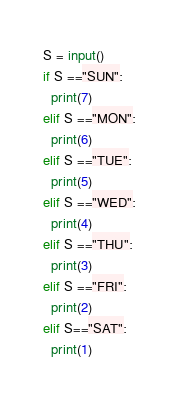Convert code to text. <code><loc_0><loc_0><loc_500><loc_500><_Python_>S = input()
if S =="SUN":
  print(7)
elif S =="MON":
  print(6)
elif S =="TUE":
  print(5)
elif S =="WED":
  print(4)
elif S =="THU":
  print(3)
elif S =="FRI":
  print(2)
elif S=="SAT":
  print(1)</code> 